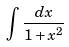Convert formula to latex. <formula><loc_0><loc_0><loc_500><loc_500>\int \frac { d x } { 1 + x ^ { 2 } }</formula> 